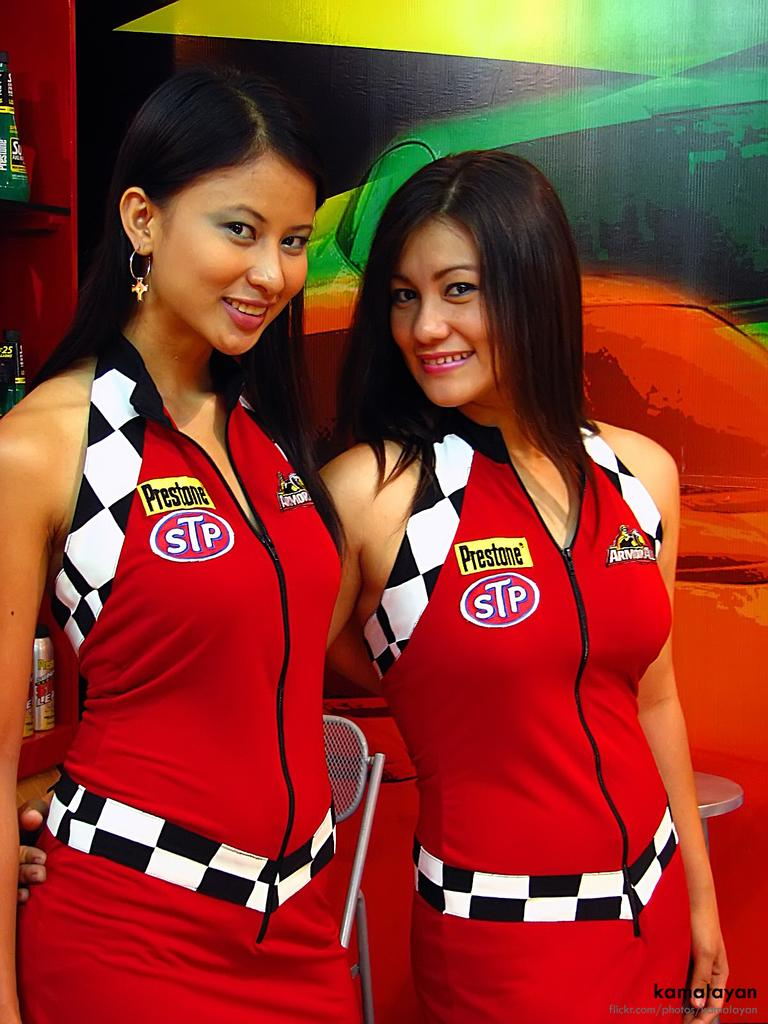Provide a one-sentence caption for the provided image. Two young models wear uniforms with the STP logo on them. 